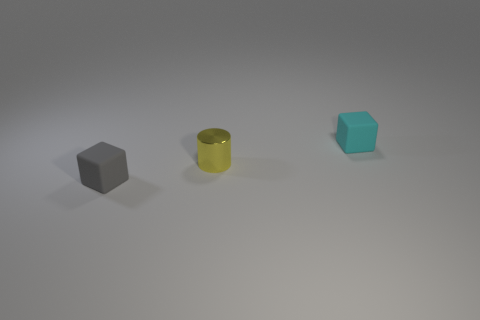Are there any other things that have the same shape as the small gray matte object? Yes, the small gray matte object is a cube, and numerous items share this shape, such as dice, sugar cubes, and many types of boxes. It's a six-faced figure with all angles right and sides of equal length, which makes it a common shape in various contexts. 